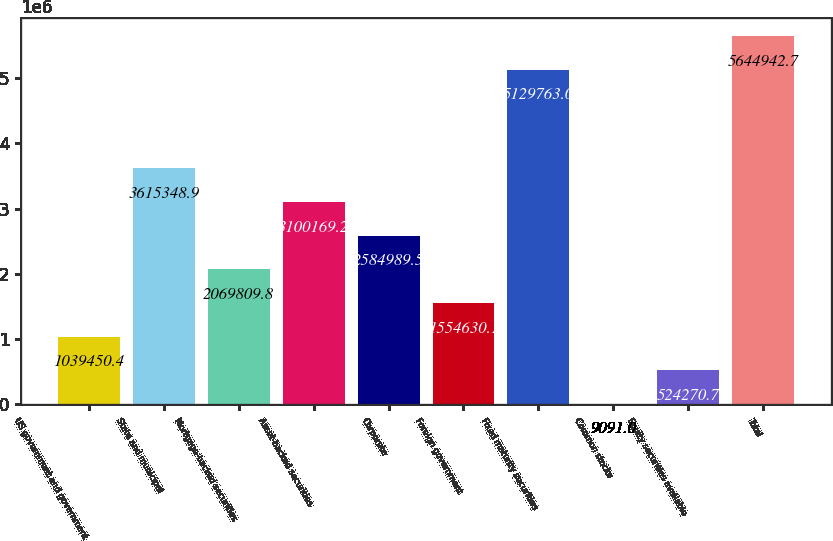Convert chart to OTSL. <chart><loc_0><loc_0><loc_500><loc_500><bar_chart><fcel>US government and government<fcel>State and municipal<fcel>Mortgage-backed securities<fcel>Asset-backed securities<fcel>Corporate<fcel>Foreign government<fcel>Fixed maturity securities<fcel>Common stocks<fcel>Equity securities available<fcel>Total<nl><fcel>1.03945e+06<fcel>3.61535e+06<fcel>2.06981e+06<fcel>3.10017e+06<fcel>2.58499e+06<fcel>1.55463e+06<fcel>5.12976e+06<fcel>9091<fcel>524271<fcel>5.64494e+06<nl></chart> 